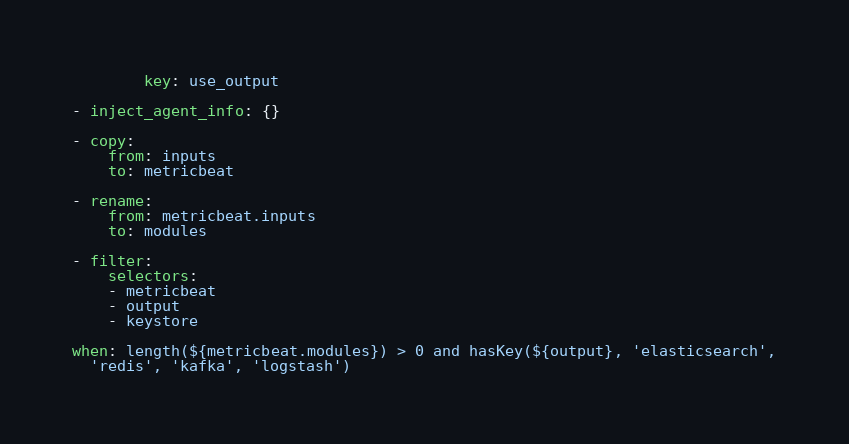<code> <loc_0><loc_0><loc_500><loc_500><_YAML_>        key: use_output

- inject_agent_info: {}

- copy:
    from: inputs
    to: metricbeat

- rename:
    from: metricbeat.inputs
    to: modules

- filter:
    selectors:
    - metricbeat
    - output
    - keystore

when: length(${metricbeat.modules}) > 0 and hasKey(${output}, 'elasticsearch',
  'redis', 'kafka', 'logstash')
</code> 